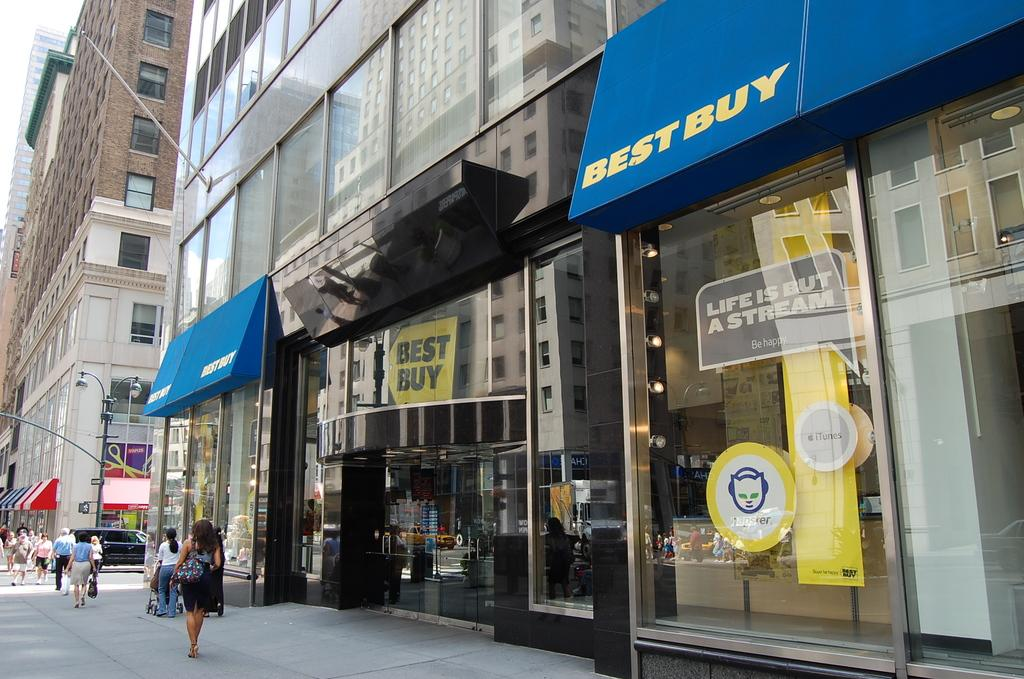What type of structures can be seen in the image? There are buildings in the image. What type of establishments can be found in the image? There are stores in the image. How can the stores be identified in the image? Name boards are present in the image. What type of infrastructure is visible in the image? Street poles and street lights are present in the image. What type of transportation is present in the image? Motor vehicles are in the image. What type of activity can be observed in the image? Persons are walking on the road in the image. Can you tell me how many bats are hanging from the grandmother's throat in the image? There is no grandmother or bat present in the image. What type of creature is sitting on the street light in the image? There is no creature sitting on the street light in the image; only motor vehicles, persons, and street lights are present. 